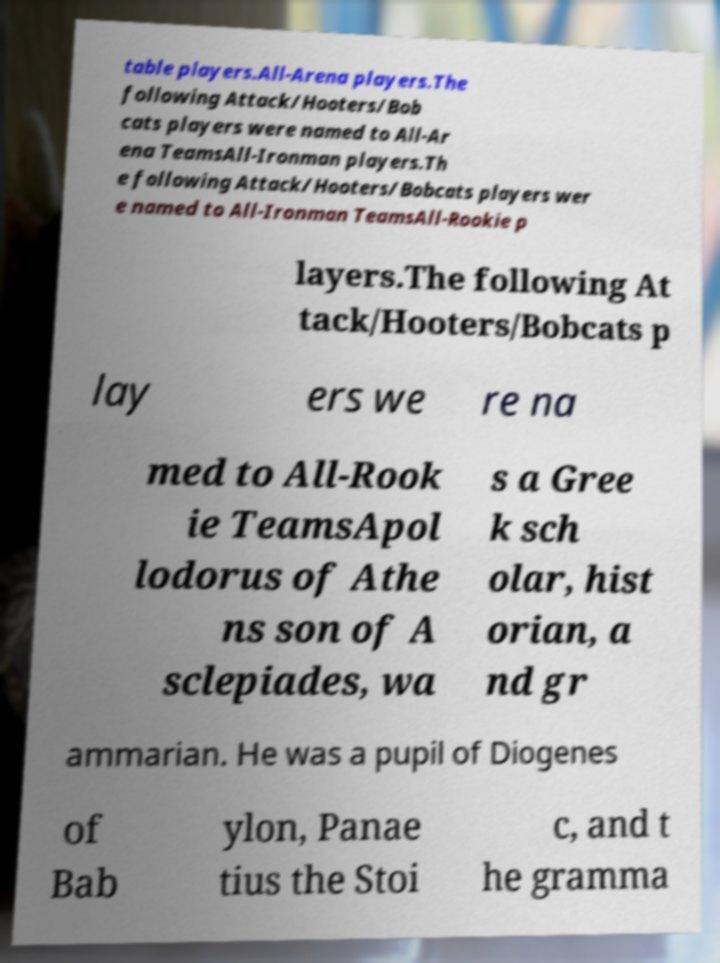What messages or text are displayed in this image? I need them in a readable, typed format. table players.All-Arena players.The following Attack/Hooters/Bob cats players were named to All-Ar ena TeamsAll-Ironman players.Th e following Attack/Hooters/Bobcats players wer e named to All-Ironman TeamsAll-Rookie p layers.The following At tack/Hooters/Bobcats p lay ers we re na med to All-Rook ie TeamsApol lodorus of Athe ns son of A sclepiades, wa s a Gree k sch olar, hist orian, a nd gr ammarian. He was a pupil of Diogenes of Bab ylon, Panae tius the Stoi c, and t he gramma 